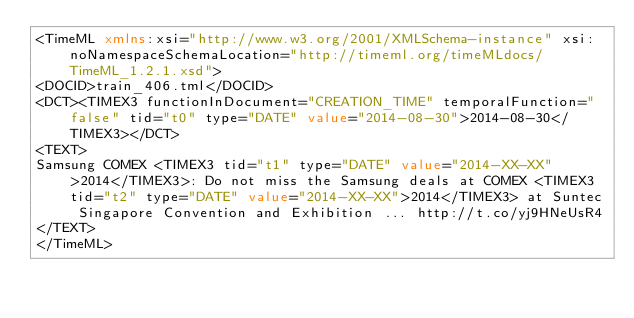<code> <loc_0><loc_0><loc_500><loc_500><_XML_><TimeML xmlns:xsi="http://www.w3.org/2001/XMLSchema-instance" xsi:noNamespaceSchemaLocation="http://timeml.org/timeMLdocs/TimeML_1.2.1.xsd">
<DOCID>train_406.tml</DOCID>
<DCT><TIMEX3 functionInDocument="CREATION_TIME" temporalFunction="false" tid="t0" type="DATE" value="2014-08-30">2014-08-30</TIMEX3></DCT>
<TEXT>
Samsung COMEX <TIMEX3 tid="t1" type="DATE" value="2014-XX-XX">2014</TIMEX3>: Do not miss the Samsung deals at COMEX <TIMEX3 tid="t2" type="DATE" value="2014-XX-XX">2014</TIMEX3> at Suntec Singapore Convention and Exhibition ... http://t.co/yj9HNeUsR4
</TEXT>
</TimeML>
</code> 